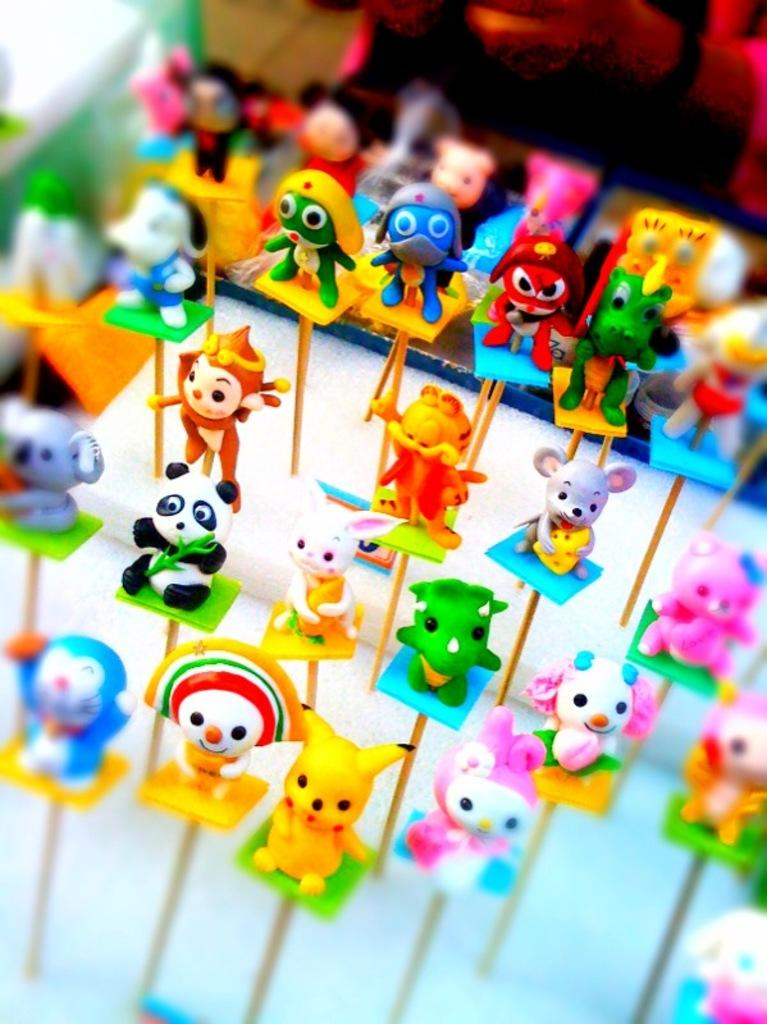What type of objects are in the image? There are colorful toys in the image. How are the toys displayed in the image? The toys are on stands. What colors can be seen on the stands? The stands have yellow, green, blue, and orange colors. Can you see the body of the person playing with the toys in the image? There is no person present in the image, so it is not possible to see their body. 